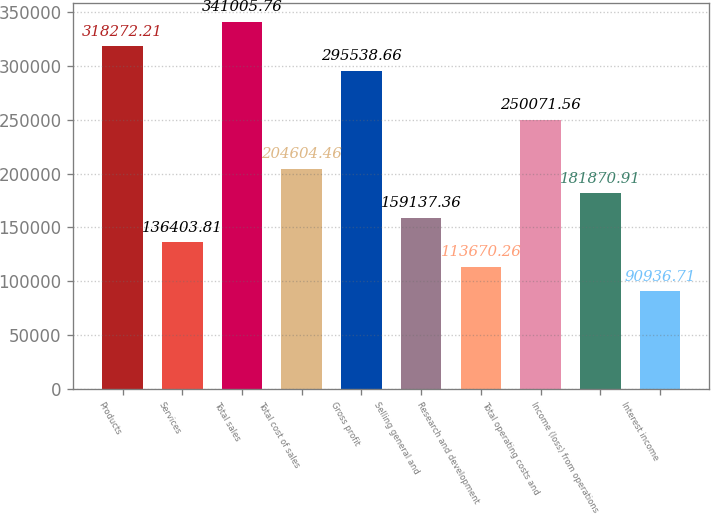<chart> <loc_0><loc_0><loc_500><loc_500><bar_chart><fcel>Products<fcel>Services<fcel>Total sales<fcel>Total cost of sales<fcel>Gross profit<fcel>Selling general and<fcel>Research and development<fcel>Total operating costs and<fcel>Income (loss) from operations<fcel>Interest income<nl><fcel>318272<fcel>136404<fcel>341006<fcel>204604<fcel>295539<fcel>159137<fcel>113670<fcel>250072<fcel>181871<fcel>90936.7<nl></chart> 